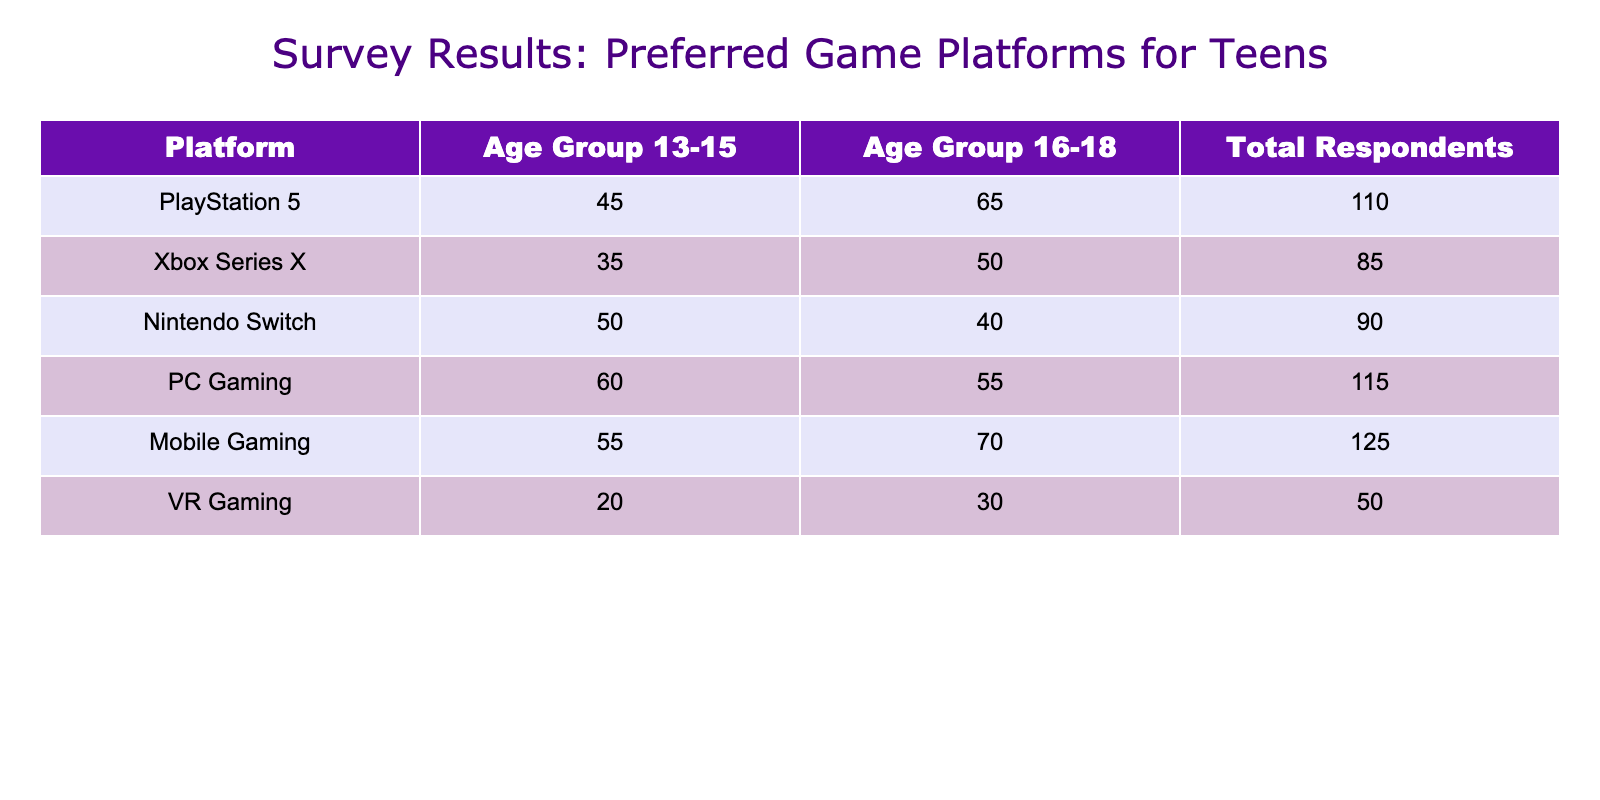What is the total number of respondents for Mobile Gaming? The total respondents for Mobile Gaming can be found directly in the table under the "Total Respondents" column for the Mobile Gaming row, which is 125.
Answer: 125 Which platform has the highest preference among the 16-18 age group? By checking the "Age Group 16-18" column, the highest value is for the PlayStation 5 with 65 respondents.
Answer: PlayStation 5 Is the number of respondents for PC Gaming higher than that for Xbox Series X? Comparing the "Total Respondents" for both platforms in the table, PC Gaming has 115 respondents while Xbox Series X has 85, so yes, PC Gaming has a higher number.
Answer: Yes What is the combined total of respondents for Nintendo Switch and Mobile Gaming? To find the combined total, we add the "Total Respondents" for Nintendo Switch (90) and Mobile Gaming (125). So, 90 + 125 = 215.
Answer: 215 Is the preference for Mobile Gaming greater than that for VR Gaming among the 13-15 age group? Looking at the "Age Group 13-15" column, Mobile Gaming has 55 respondents while VR Gaming has 20. Since 55 is greater than 20, the preference for Mobile Gaming is indeed greater.
Answer: Yes What is the average number of respondents across all platforms for the 16-18 age group? To find the average for the "Age Group 16-18," we add the respondents: 65 (PlayStation 5) + 50 (Xbox Series X) + 40 (Nintendo Switch) + 55 (PC Gaming) + 70 (Mobile Gaming) + 30 (VR Gaming) = 310. There are 6 platforms, so the average is 310 / 6 = 51.67.
Answer: 51.67 Which platform has the least number of respondents in total, and what is that number? Checking the "Total Respondents" column, the platform with the least number is VR Gaming with 50 respondents.
Answer: VR Gaming, 50 How many more respondents are there for PC Gaming compared to the Nintendo Switch in the 13-15 age group? In the "Age Group 13-15," PC Gaming has 60 respondents and Nintendo Switch has 50. Hence, 60 - 50 = 10 more respondents for PC Gaming.
Answer: 10 